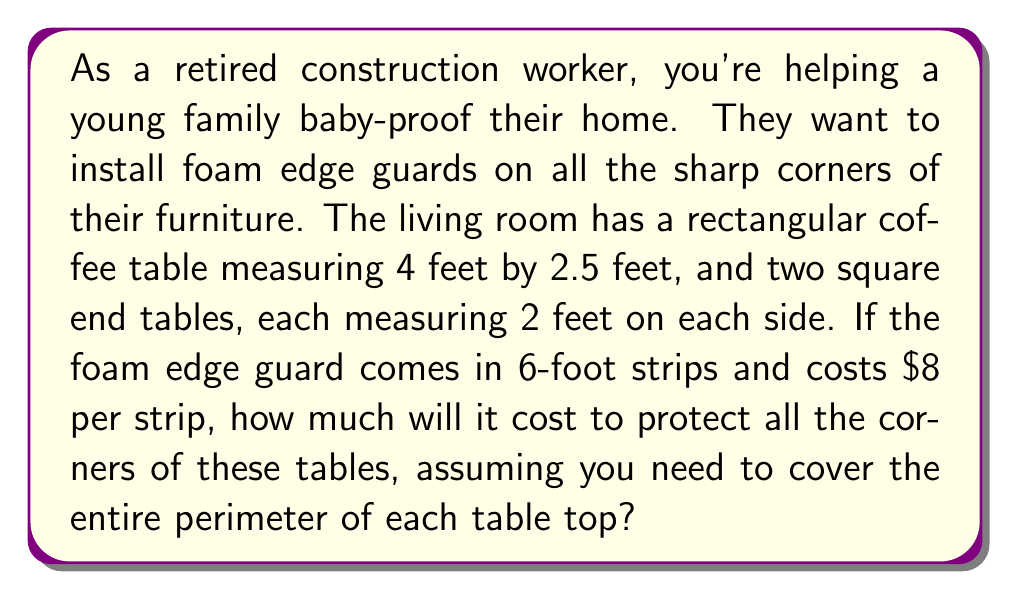Provide a solution to this math problem. Let's approach this step-by-step:

1) First, calculate the perimeter of each table:

   Coffee table: $P = 2(l + w) = 2(4 + 2.5) = 2(6.5) = 13$ feet
   
   Each end table: $P = 4s = 4(2) = 8$ feet

2) Total perimeter to cover:
   $13 + 8 + 8 = 29$ feet

3) Number of 6-foot strips needed:
   $\frac{29 \text{ feet}}{6 \text{ feet per strip}} = 4.833$

   Since we can't buy a fraction of a strip, we need to round up to 5 strips.

4) Cost calculation:
   $5 \text{ strips} \times \$8 \text{ per strip} = \$40$

Therefore, the total cost will be $40.
Answer: $40 